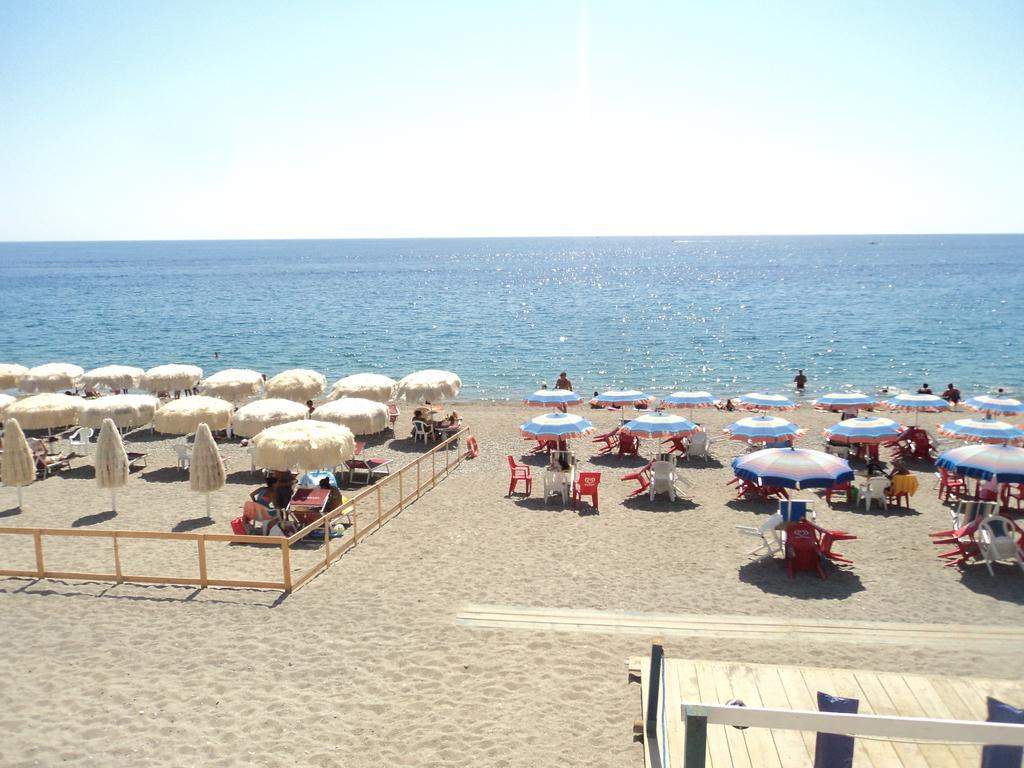What type of natural body of water is visible in the image? There is an ocean in the image. What is the land area near the ocean called? There is a beach area in the image. What furniture is present on the beach? There is a table and chairs on the beach. What type of shade is provided on the beach? There are umbrellas on the beach. What activities are people engaged in near the ocean? People are swimming in the ocean and sitting on the beach. How would you describe the sky in the image? The sky is clean in the image. What type of music is being played on the beach in the image? There is no information about music being played in the image. What is the opinion of the chin in the image? There is no chin present in the image, so it is not possible to determine an opinion. 